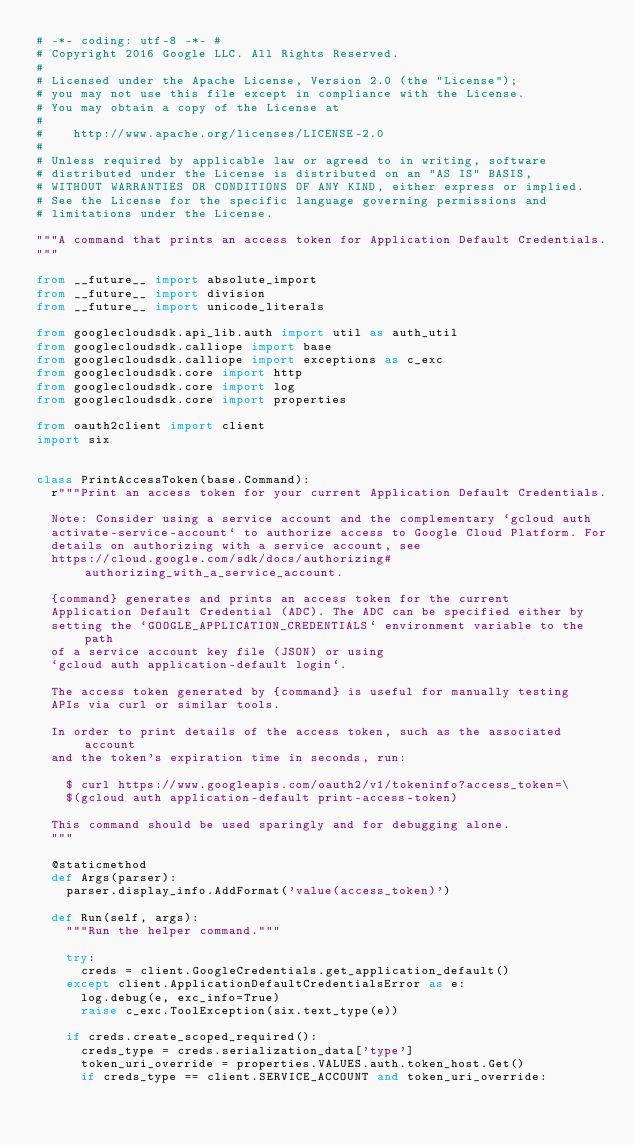Convert code to text. <code><loc_0><loc_0><loc_500><loc_500><_Python_># -*- coding: utf-8 -*- #
# Copyright 2016 Google LLC. All Rights Reserved.
#
# Licensed under the Apache License, Version 2.0 (the "License");
# you may not use this file except in compliance with the License.
# You may obtain a copy of the License at
#
#    http://www.apache.org/licenses/LICENSE-2.0
#
# Unless required by applicable law or agreed to in writing, software
# distributed under the License is distributed on an "AS IS" BASIS,
# WITHOUT WARRANTIES OR CONDITIONS OF ANY KIND, either express or implied.
# See the License for the specific language governing permissions and
# limitations under the License.

"""A command that prints an access token for Application Default Credentials.
"""

from __future__ import absolute_import
from __future__ import division
from __future__ import unicode_literals

from googlecloudsdk.api_lib.auth import util as auth_util
from googlecloudsdk.calliope import base
from googlecloudsdk.calliope import exceptions as c_exc
from googlecloudsdk.core import http
from googlecloudsdk.core import log
from googlecloudsdk.core import properties

from oauth2client import client
import six


class PrintAccessToken(base.Command):
  r"""Print an access token for your current Application Default Credentials.

  Note: Consider using a service account and the complementary `gcloud auth
  activate-service-account` to authorize access to Google Cloud Platform. For
  details on authorizing with a service account, see
  https://cloud.google.com/sdk/docs/authorizing#authorizing_with_a_service_account.

  {command} generates and prints an access token for the current
  Application Default Credential (ADC). The ADC can be specified either by
  setting the `GOOGLE_APPLICATION_CREDENTIALS` environment variable to the path
  of a service account key file (JSON) or using
  `gcloud auth application-default login`.

  The access token generated by {command} is useful for manually testing
  APIs via curl or similar tools.

  In order to print details of the access token, such as the associated account
  and the token's expiration time in seconds, run:

    $ curl https://www.googleapis.com/oauth2/v1/tokeninfo?access_token=\
    $(gcloud auth application-default print-access-token)

  This command should be used sparingly and for debugging alone.
  """

  @staticmethod
  def Args(parser):
    parser.display_info.AddFormat('value(access_token)')

  def Run(self, args):
    """Run the helper command."""

    try:
      creds = client.GoogleCredentials.get_application_default()
    except client.ApplicationDefaultCredentialsError as e:
      log.debug(e, exc_info=True)
      raise c_exc.ToolException(six.text_type(e))

    if creds.create_scoped_required():
      creds_type = creds.serialization_data['type']
      token_uri_override = properties.VALUES.auth.token_host.Get()
      if creds_type == client.SERVICE_ACCOUNT and token_uri_override:</code> 